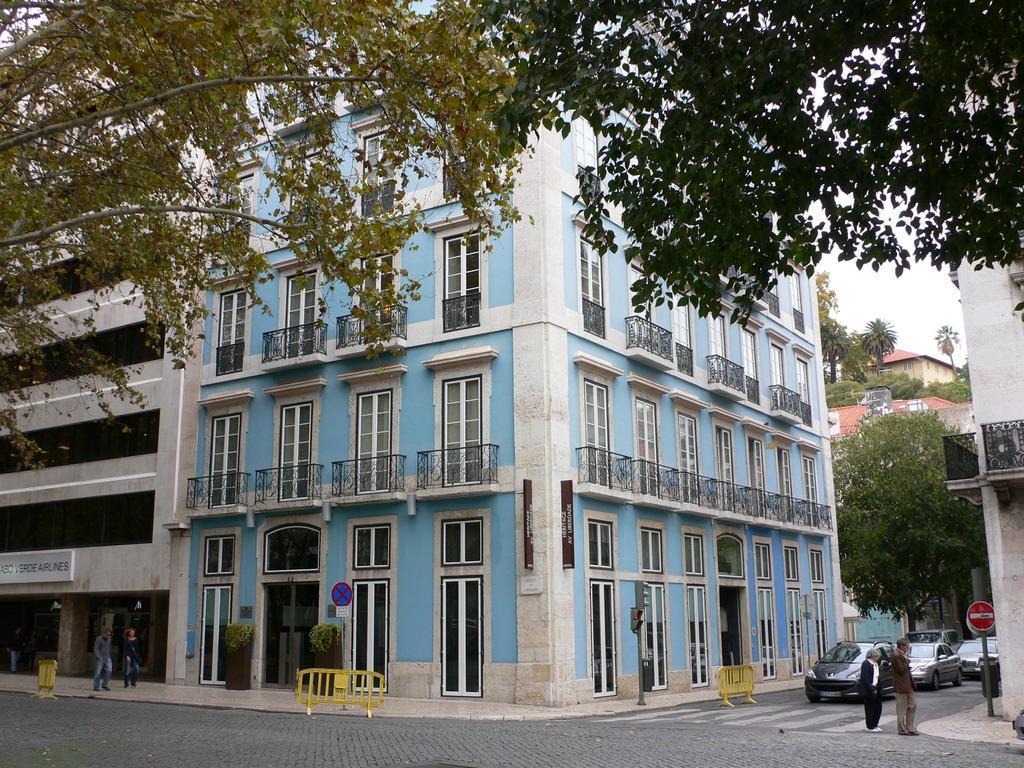In one or two sentences, can you explain what this image depicts? In this image we can see few buildings, trees, people standing near the buildings, there are few vehicles and barricades on the road and the sky in the background. 